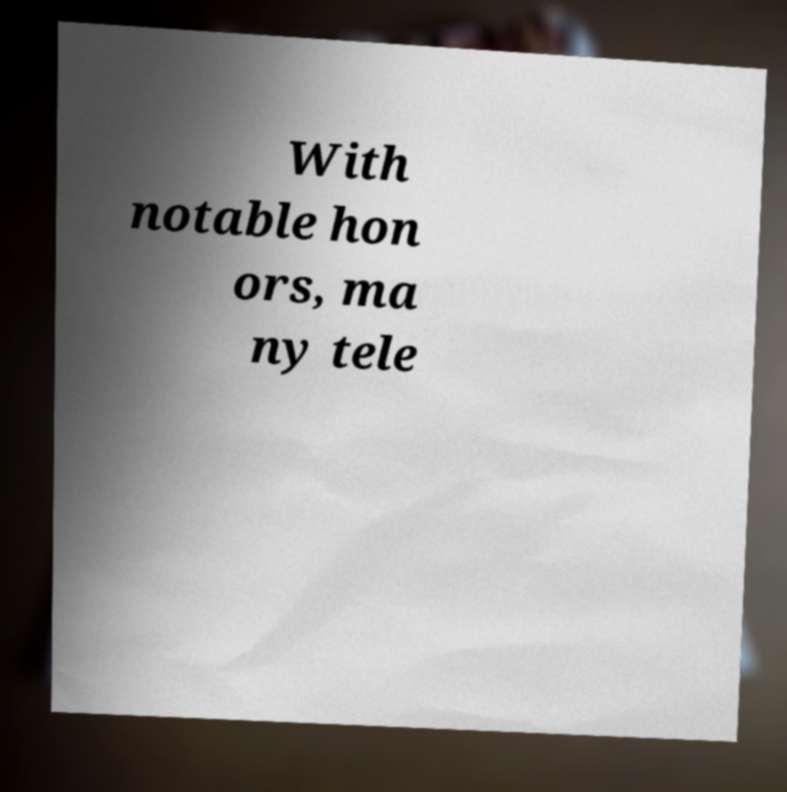Could you extract and type out the text from this image? With notable hon ors, ma ny tele 